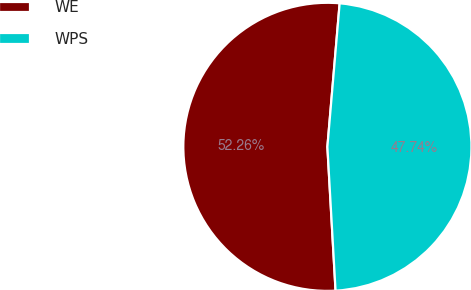Convert chart. <chart><loc_0><loc_0><loc_500><loc_500><pie_chart><fcel>WE<fcel>WPS<nl><fcel>52.26%<fcel>47.74%<nl></chart> 